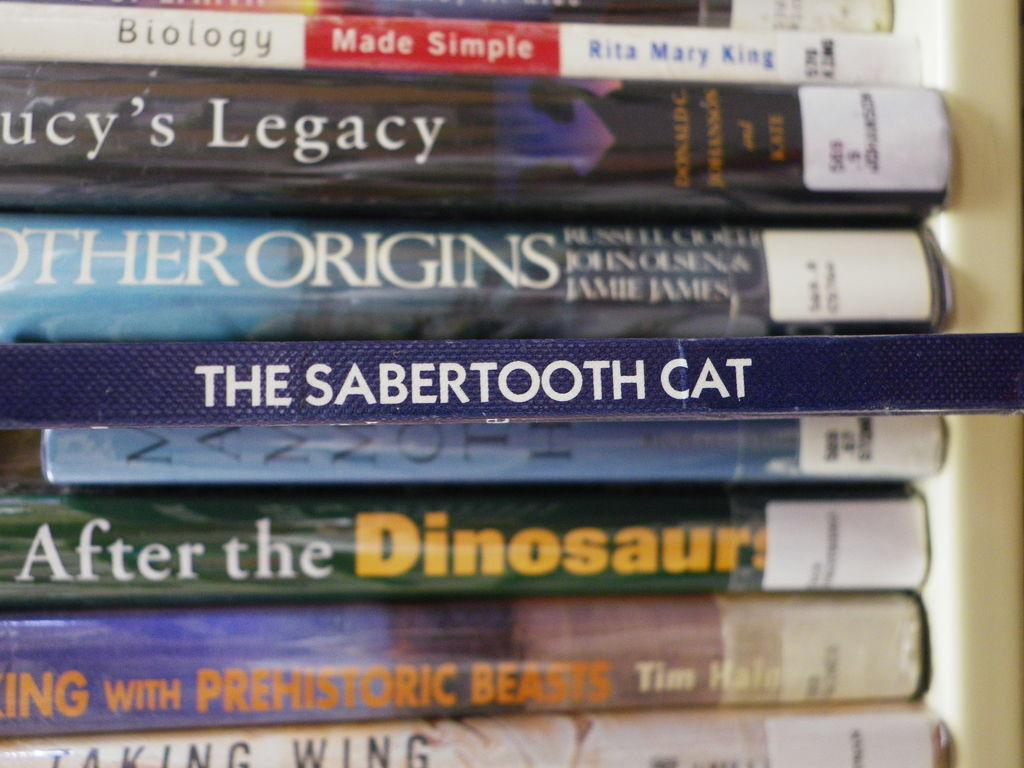<image>
Offer a succinct explanation of the picture presented. A stack of library books about prehistoric animals. 